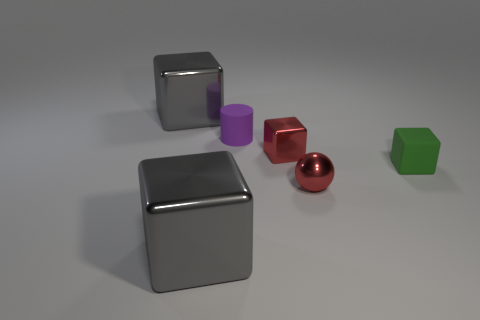Subtract all green blocks. How many blocks are left? 3 Add 1 big gray matte objects. How many objects exist? 7 Subtract all purple cylinders. How many gray cubes are left? 2 Subtract all red blocks. How many blocks are left? 3 Subtract all blocks. How many objects are left? 2 Subtract all brown spheres. Subtract all cyan blocks. How many spheres are left? 1 Subtract all gray metallic objects. Subtract all gray metallic objects. How many objects are left? 2 Add 1 tiny blocks. How many tiny blocks are left? 3 Add 2 tiny green matte cubes. How many tiny green matte cubes exist? 3 Subtract 0 cyan balls. How many objects are left? 6 